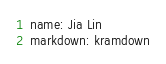Convert code to text. <code><loc_0><loc_0><loc_500><loc_500><_YAML_>name: Jia Lin
markdown: kramdown
</code> 